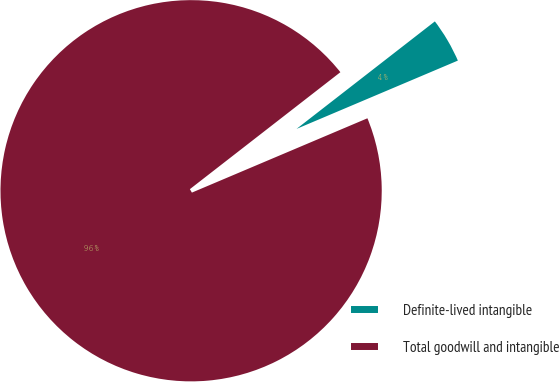Convert chart. <chart><loc_0><loc_0><loc_500><loc_500><pie_chart><fcel>Definite-lived intangible<fcel>Total goodwill and intangible<nl><fcel>4.14%<fcel>95.86%<nl></chart> 